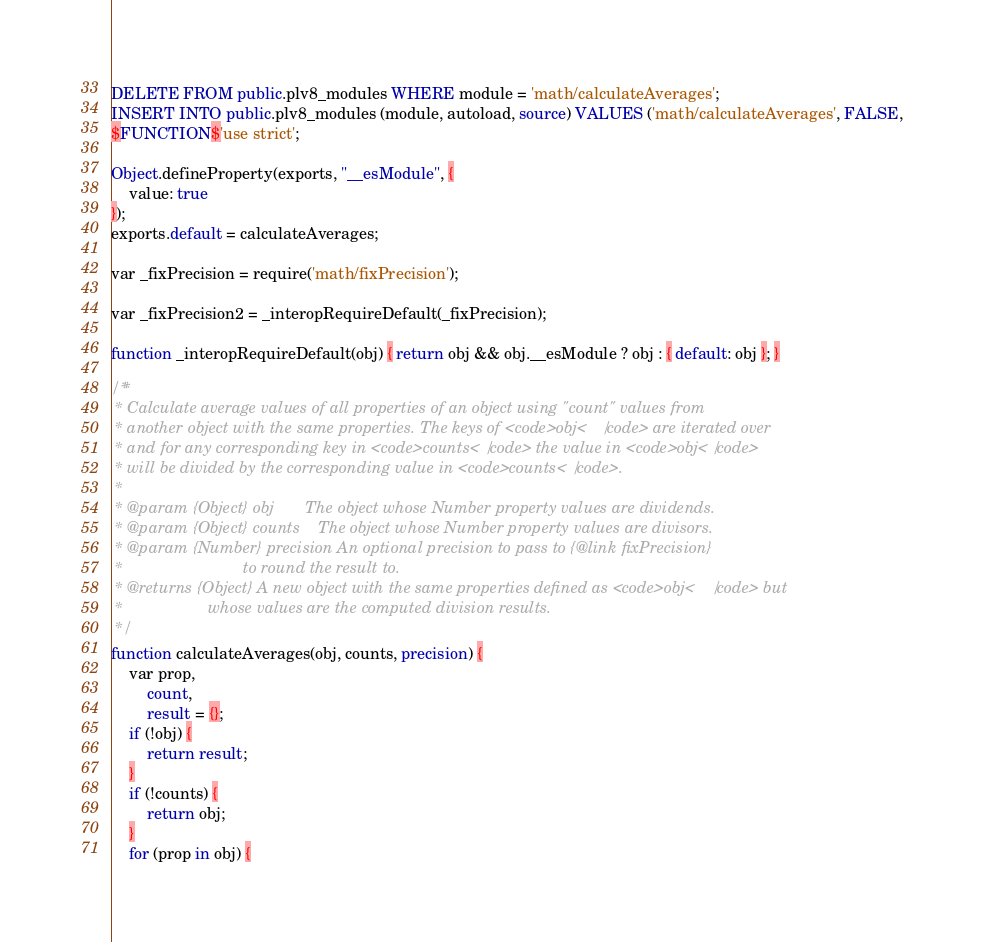Convert code to text. <code><loc_0><loc_0><loc_500><loc_500><_SQL_>DELETE FROM public.plv8_modules WHERE module = 'math/calculateAverages';
INSERT INTO public.plv8_modules (module, autoload, source) VALUES ('math/calculateAverages', FALSE,
$FUNCTION$'use strict';

Object.defineProperty(exports, "__esModule", {
	value: true
});
exports.default = calculateAverages;

var _fixPrecision = require('math/fixPrecision');

var _fixPrecision2 = _interopRequireDefault(_fixPrecision);

function _interopRequireDefault(obj) { return obj && obj.__esModule ? obj : { default: obj }; }

/**
 * Calculate average values of all properties of an object using "count" values from
 * another object with the same properties. The keys of <code>obj</code> are iterated over
 * and for any corresponding key in <code>counts</code> the value in <code>obj</code>
 * will be divided by the corresponding value in <code>counts</code>.
 *
 * @param {Object} obj       The object whose Number property values are dividends.
 * @param {Object} counts    The object whose Number property values are divisors.
 * @param {Number} precision An optional precision to pass to {@link fixPrecision}
 *                           to round the result to.
 * @returns {Object} A new object with the same properties defined as <code>obj</code> but
 *                   whose values are the computed division results.
 */
function calculateAverages(obj, counts, precision) {
	var prop,
	    count,
	    result = {};
	if (!obj) {
		return result;
	}
	if (!counts) {
		return obj;
	}
	for (prop in obj) {</code> 